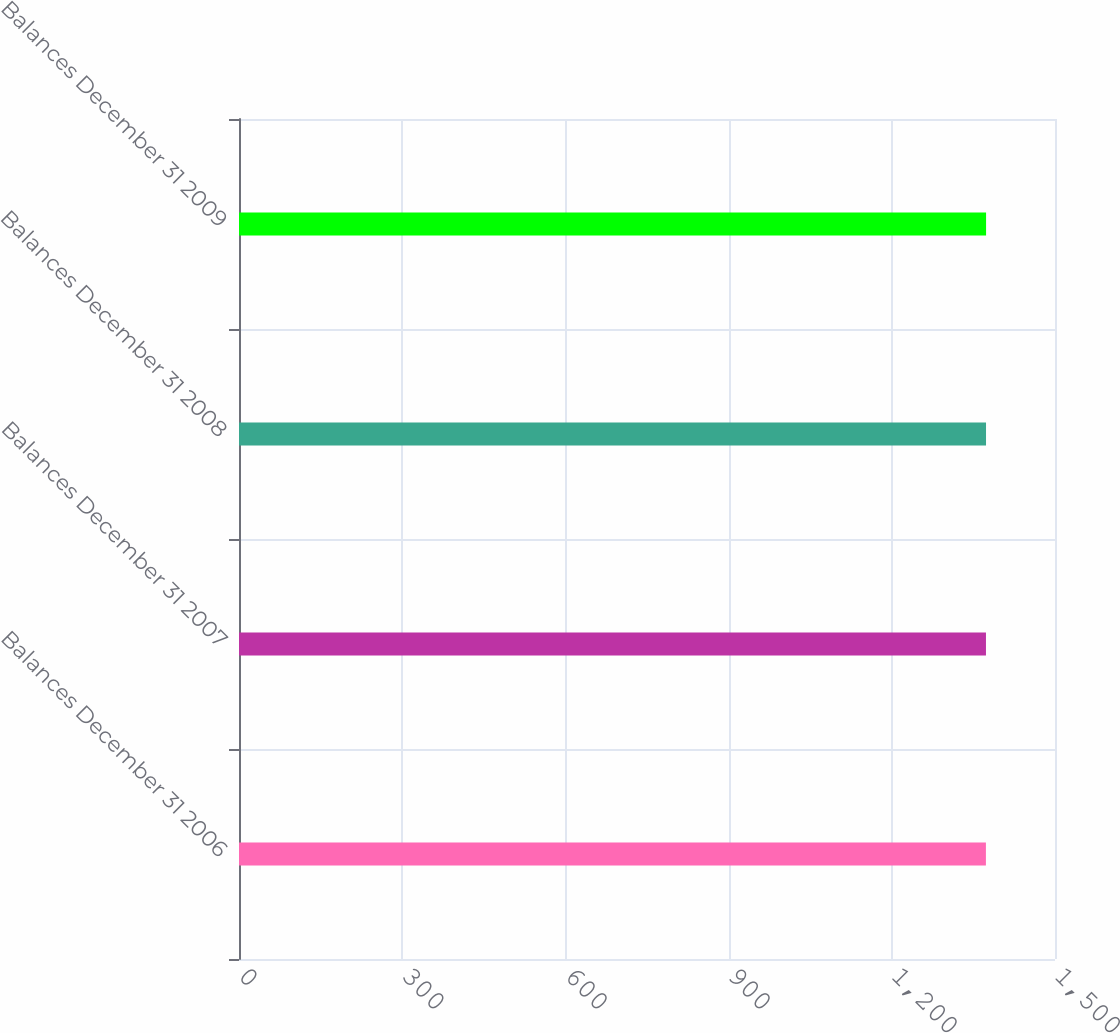<chart> <loc_0><loc_0><loc_500><loc_500><bar_chart><fcel>Balances December 31 2006<fcel>Balances December 31 2007<fcel>Balances December 31 2008<fcel>Balances December 31 2009<nl><fcel>1373<fcel>1373.1<fcel>1373.2<fcel>1373.3<nl></chart> 